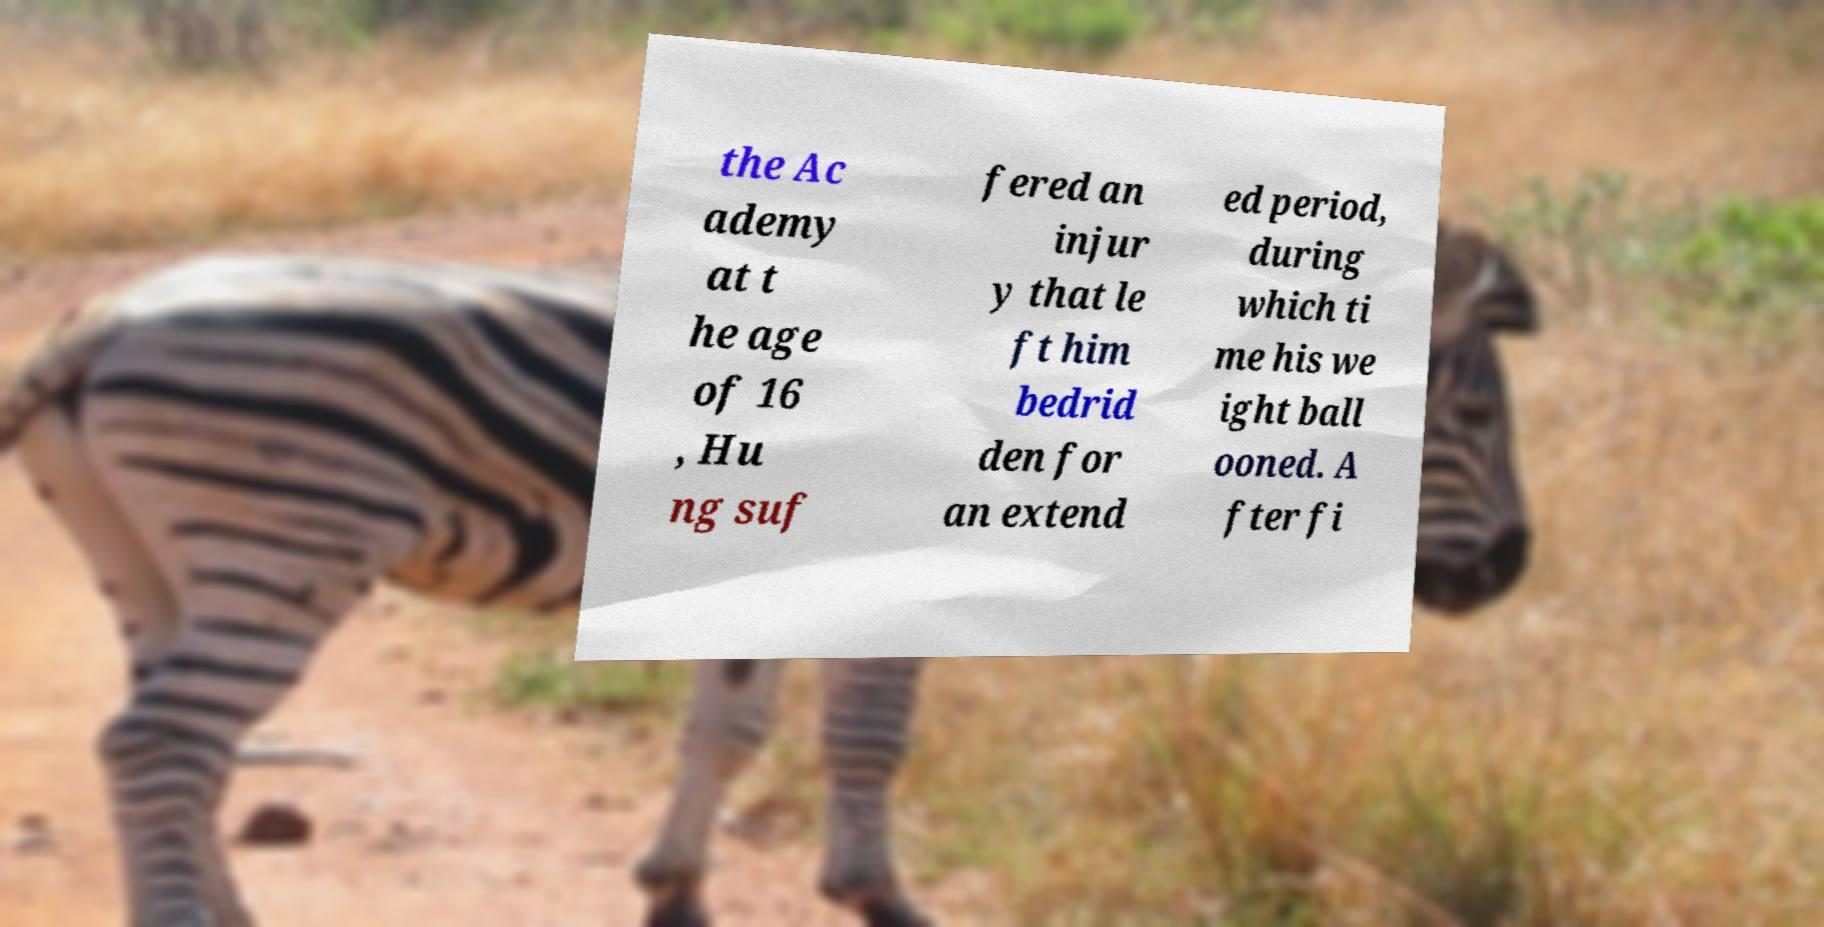For documentation purposes, I need the text within this image transcribed. Could you provide that? the Ac ademy at t he age of 16 , Hu ng suf fered an injur y that le ft him bedrid den for an extend ed period, during which ti me his we ight ball ooned. A fter fi 